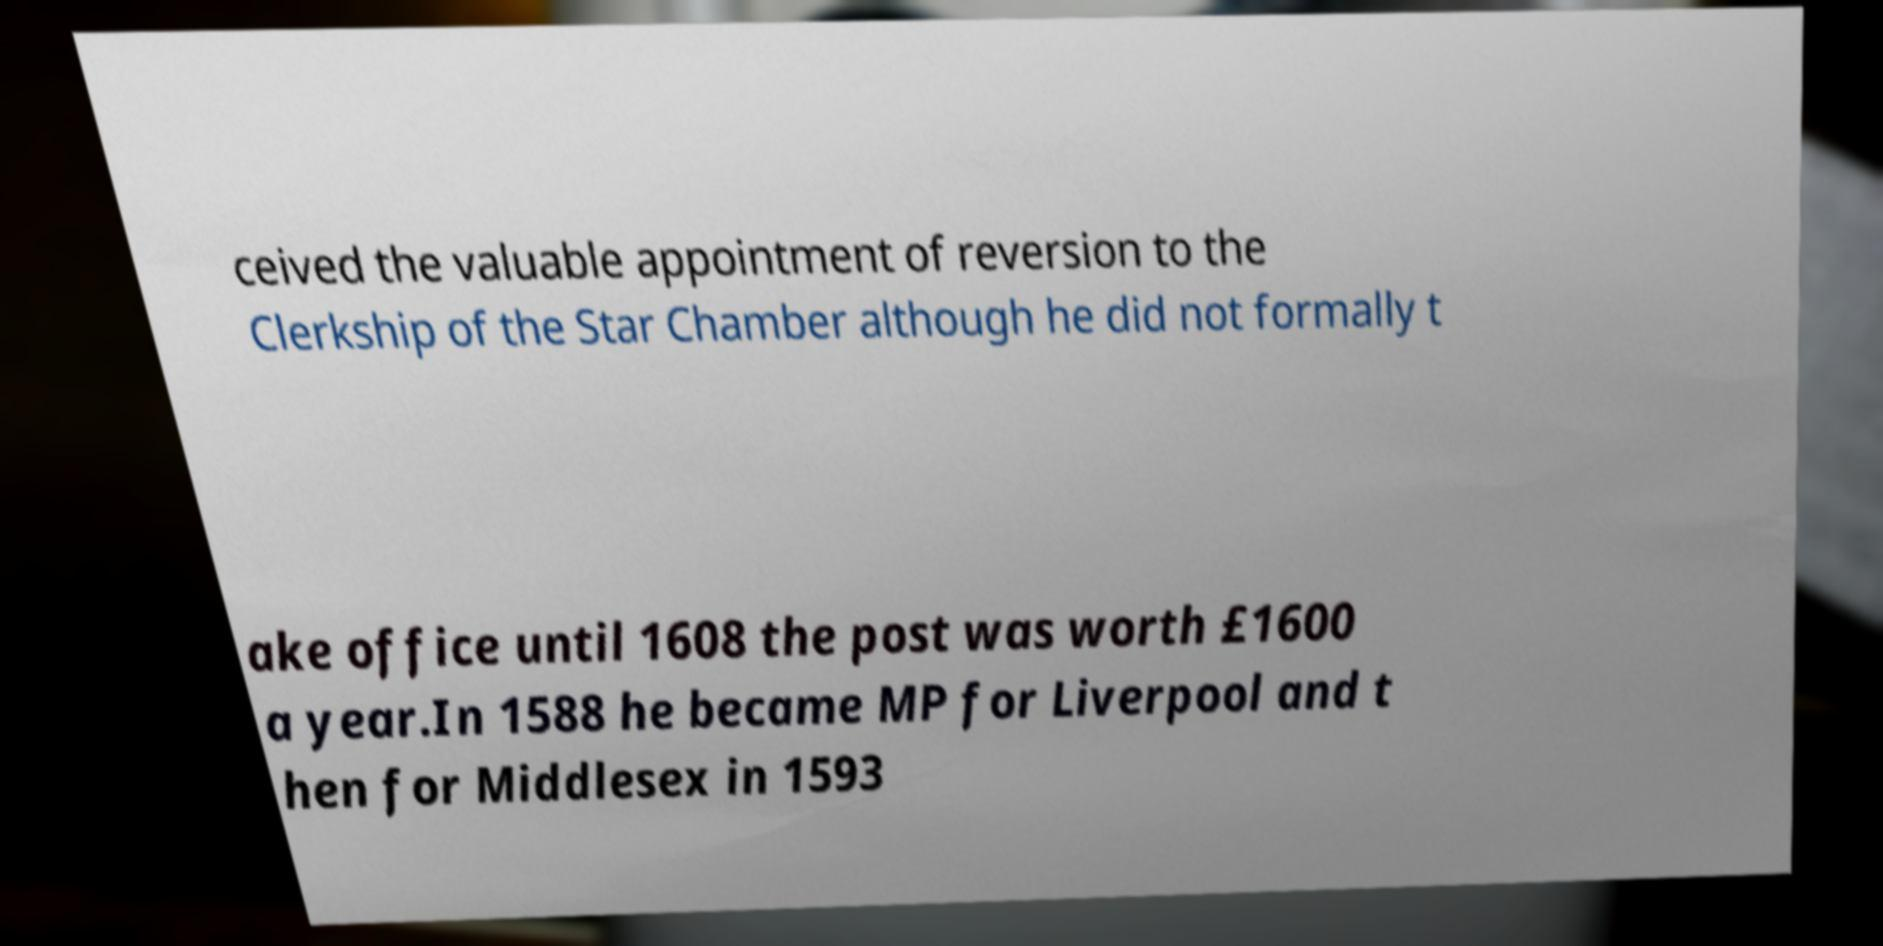I need the written content from this picture converted into text. Can you do that? ceived the valuable appointment of reversion to the Clerkship of the Star Chamber although he did not formally t ake office until 1608 the post was worth £1600 a year.In 1588 he became MP for Liverpool and t hen for Middlesex in 1593 